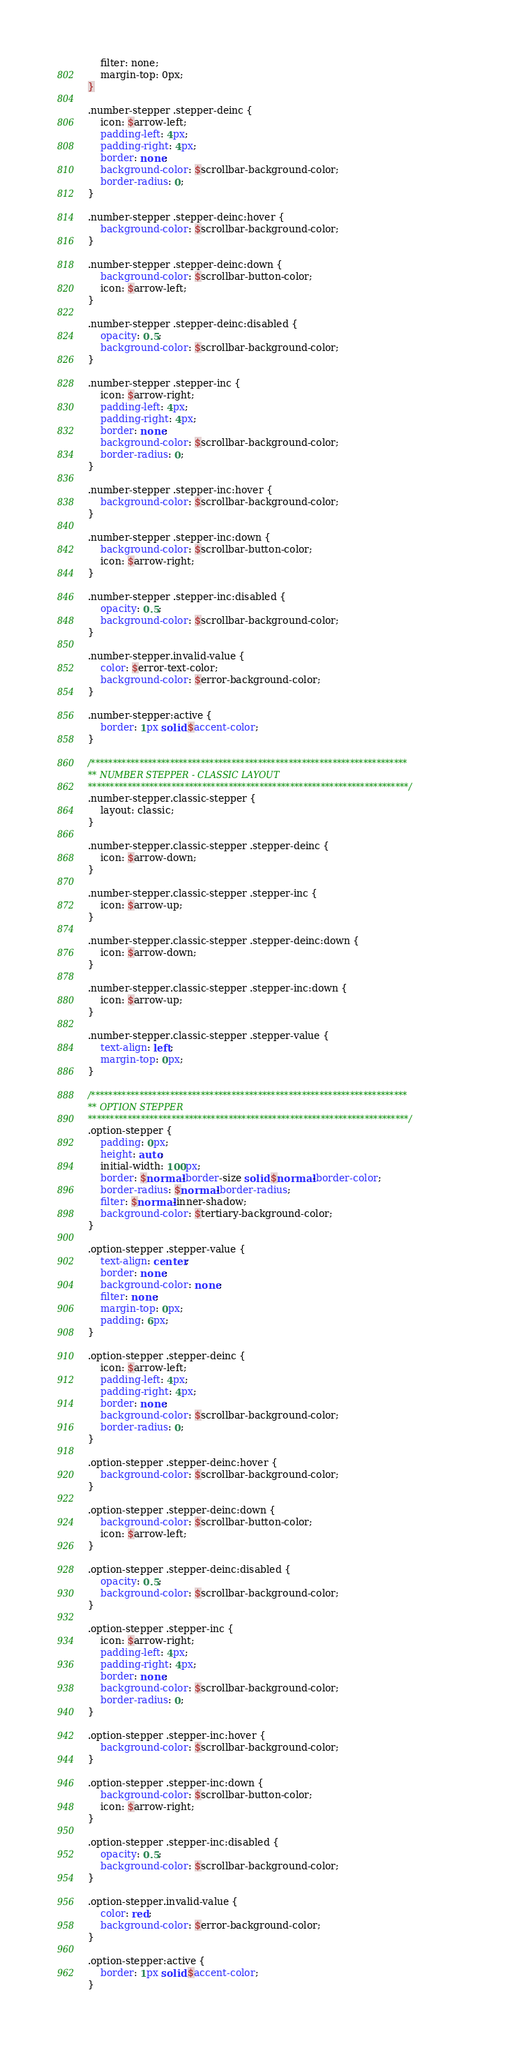<code> <loc_0><loc_0><loc_500><loc_500><_CSS_>    filter: none;
    margin-top: 0px;
}

.number-stepper .stepper-deinc {
    icon: $arrow-left;
    padding-left: 4px;
    padding-right: 4px;
    border: none;
    background-color: $scrollbar-background-color;
    border-radius: 0;
}

.number-stepper .stepper-deinc:hover {
    background-color: $scrollbar-background-color;
}

.number-stepper .stepper-deinc:down {
    background-color: $scrollbar-button-color;
    icon: $arrow-left;
}

.number-stepper .stepper-deinc:disabled {
    opacity: 0.5;
    background-color: $scrollbar-background-color;
}

.number-stepper .stepper-inc {
    icon: $arrow-right;
    padding-left: 4px;
    padding-right: 4px;
    border: none;
    background-color: $scrollbar-background-color;
    border-radius: 0;
}

.number-stepper .stepper-inc:hover {
    background-color: $scrollbar-background-color;
}

.number-stepper .stepper-inc:down {
    background-color: $scrollbar-button-color;
    icon: $arrow-right;
}

.number-stepper .stepper-inc:disabled {
    opacity: 0.5;
    background-color: $scrollbar-background-color;
}

.number-stepper.invalid-value {
    color: $error-text-color;
    background-color: $error-background-color;
}

.number-stepper:active {
    border: 1px solid $accent-color;
}

/************************************************************************
** NUMBER STEPPER - CLASSIC LAYOUT
*************************************************************************/
.number-stepper.classic-stepper {
    layout: classic;
}

.number-stepper.classic-stepper .stepper-deinc {
    icon: $arrow-down;
}

.number-stepper.classic-stepper .stepper-inc {
    icon: $arrow-up;
}

.number-stepper.classic-stepper .stepper-deinc:down {
    icon: $arrow-down;
}

.number-stepper.classic-stepper .stepper-inc:down {
    icon: $arrow-up;
}

.number-stepper.classic-stepper .stepper-value {
    text-align: left;
    margin-top: 0px;
}

/************************************************************************
** OPTION STEPPER
*************************************************************************/
.option-stepper {
    padding: 0px;
    height: auto;
    initial-width: 100px;
    border: $normal-border-size solid $normal-border-color;
    border-radius: $normal-border-radius;
    filter: $normal-inner-shadow;
    background-color: $tertiary-background-color;
}

.option-stepper .stepper-value {
    text-align: center;
    border: none;
    background-color: none;
    filter: none;
    margin-top: 0px;
    padding: 6px;
}

.option-stepper .stepper-deinc {
    icon: $arrow-left;
    padding-left: 4px;
    padding-right: 4px;
    border: none;
    background-color: $scrollbar-background-color;
    border-radius: 0;
}

.option-stepper .stepper-deinc:hover {
    background-color: $scrollbar-background-color;
}

.option-stepper .stepper-deinc:down {
    background-color: $scrollbar-button-color;
    icon: $arrow-left;
}

.option-stepper .stepper-deinc:disabled {
    opacity: 0.5;
    background-color: $scrollbar-background-color;
}

.option-stepper .stepper-inc {
    icon: $arrow-right;
    padding-left: 4px;
    padding-right: 4px;
    border: none;
    background-color: $scrollbar-background-color;
    border-radius: 0;
}

.option-stepper .stepper-inc:hover {
    background-color: $scrollbar-background-color;
}

.option-stepper .stepper-inc:down {
    background-color: $scrollbar-button-color;
    icon: $arrow-right;
}

.option-stepper .stepper-inc:disabled {
    opacity: 0.5;
    background-color: $scrollbar-background-color;
}

.option-stepper.invalid-value {
    color: red;
    background-color: $error-background-color;
}

.option-stepper:active {
    border: 1px solid $accent-color;
}
</code> 